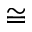Convert formula to latex. <formula><loc_0><loc_0><loc_500><loc_500>\cong</formula> 